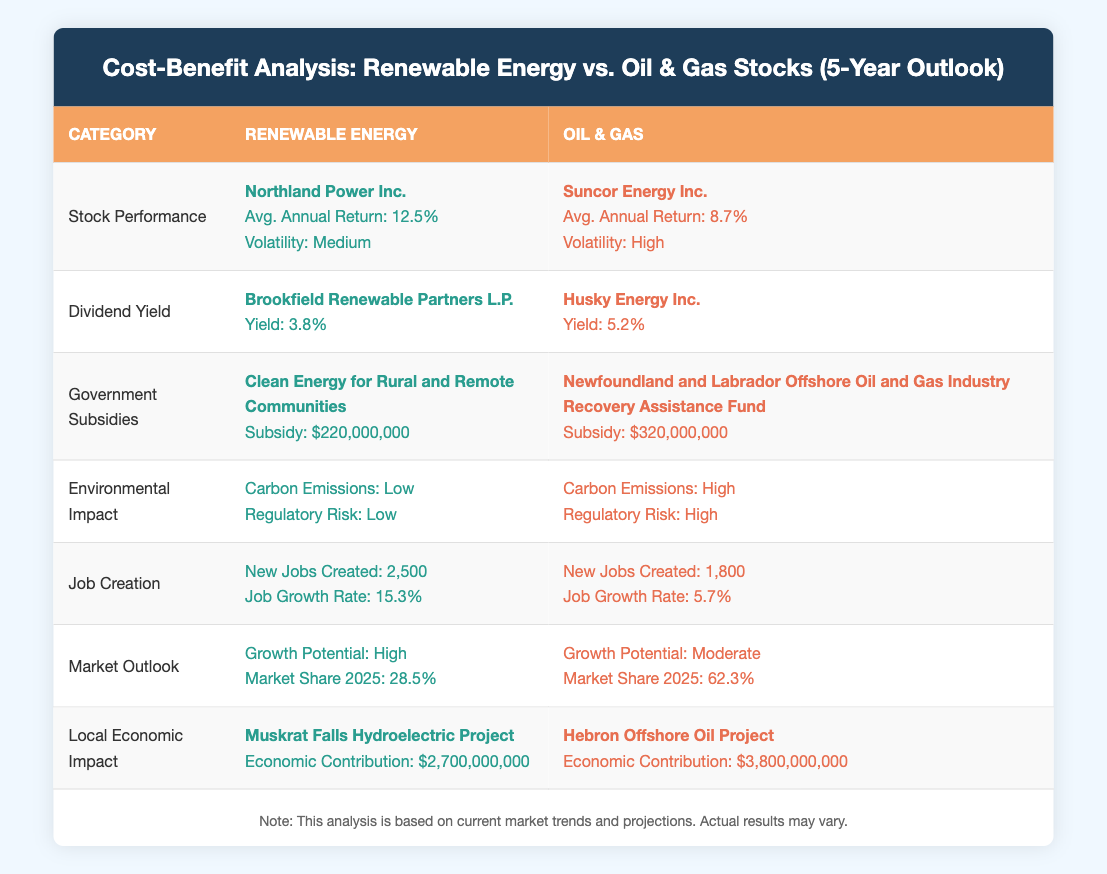What is the average annual return for renewable energy stocks? The table indicates that Northland Power Inc., a renewable energy company, has an average annual return of 12.5%.
Answer: 12.5% What is the dividend yield of oil and gas stocks? From the table, Husky Energy Inc., representing oil and gas stocks, has a dividend yield of 5.2%.
Answer: 5.2% Which sector has a higher job growth rate? Renewable energy has a job growth rate of 15.3% (2500 new jobs), while oil and gas has a job growth rate of 5.7% (1800 new jobs). Since 15.3% > 5.7%, renewable energy has a higher growth rate.
Answer: Renewable energy What is the difference in subsidy amounts between the oil and gas and renewable energy sectors? The oil and gas sector has a subsidy amount of $320,000,000, while the renewable sector has $220,000,000. The difference is $320,000,000 - $220,000,000 = $100,000,000.
Answer: 100,000,000 Are the carbon emissions for renewable energy stocks considered high? According to the table, renewable energy stocks have low carbon emissions, which means the statement is false.
Answer: No Which project contributes more economically, the Muskrat Falls Hydroelectric Project or the Hebron Offshore Oil Project? The economic contributions are stated as $2,700,000,000 for the Muskrat Falls project and $3,800,000,000 for the Hebron project. Since $3,800,000,000 > $2,700,000,000, Hebron has a higher contribution.
Answer: Hebron Offshore Oil Project Is the growth potential of renewable energy higher than that of oil and gas? The table states the growth potential for renewable energy is high, while for oil and gas it is moderate. Since high is greater than moderate, the statement is true.
Answer: Yes What are the respective carbon emissions for renewable energy and oil and gas stocks? For renewable energy, carbon emissions are low; for oil and gas, they are high as indicated in the table.
Answer: Low; High How many new jobs will be created in the renewable energy sector compared to oil and gas? The table indicates that renewable energy will create 2,500 new jobs, while oil and gas will create 1,800 new jobs. Thus, the renewable sector creates more jobs.
Answer: 2,500; 1,800 